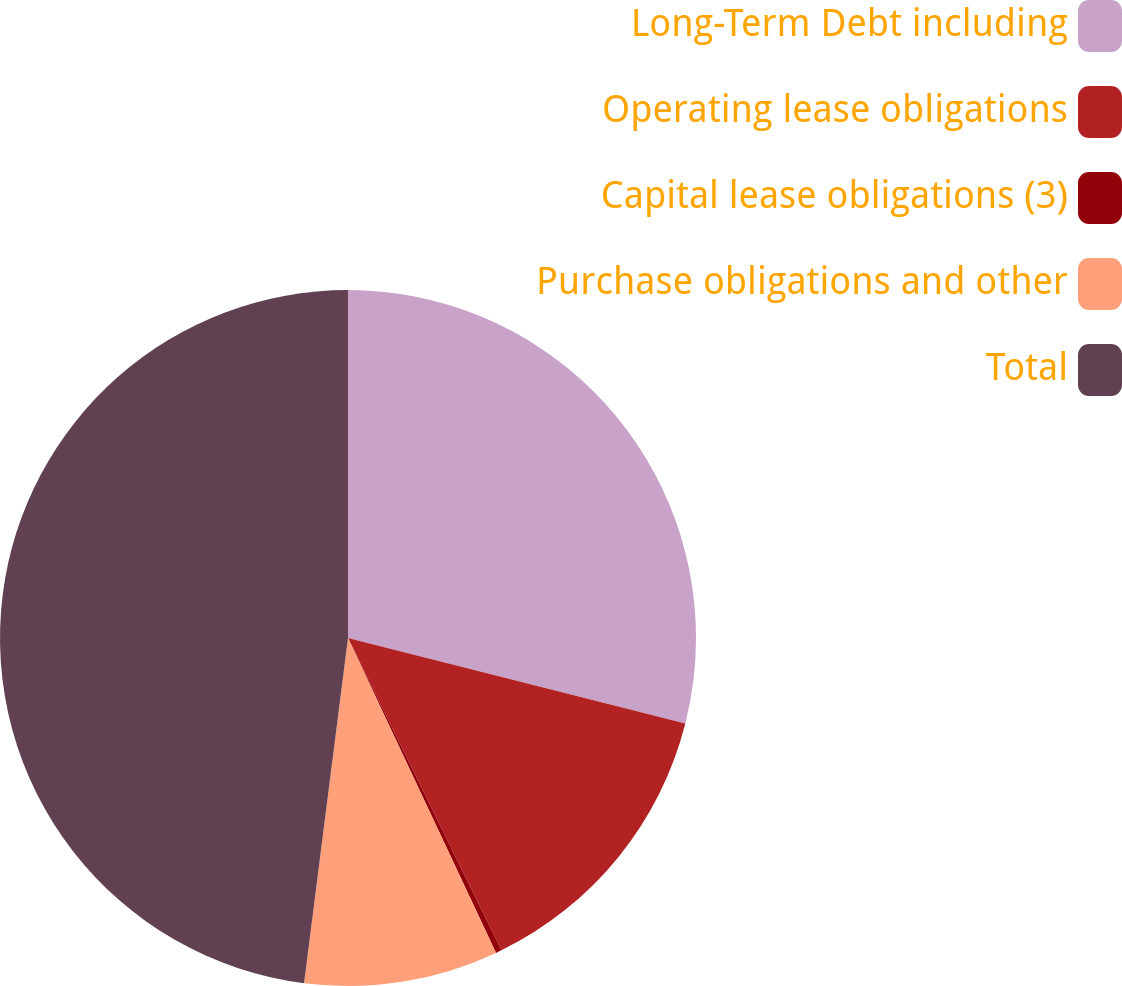<chart> <loc_0><loc_0><loc_500><loc_500><pie_chart><fcel>Long-Term Debt including<fcel>Operating lease obligations<fcel>Capital lease obligations (3)<fcel>Purchase obligations and other<fcel>Total<nl><fcel>28.95%<fcel>13.78%<fcel>0.27%<fcel>9.01%<fcel>47.98%<nl></chart> 